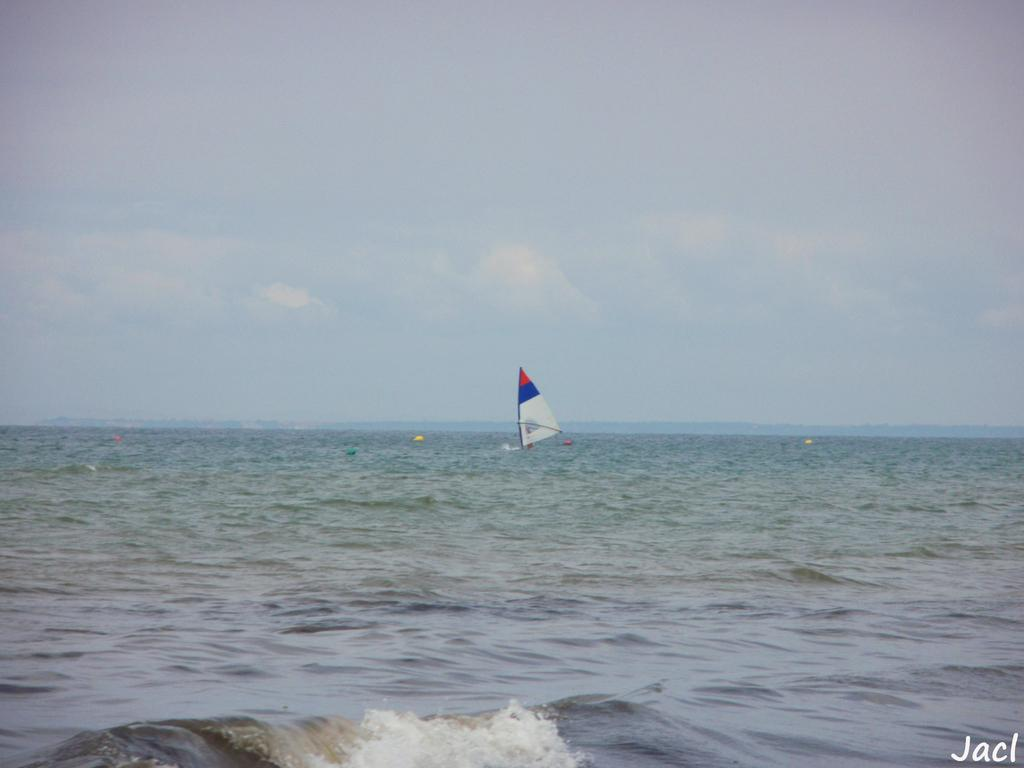What is the primary element in the image? There is water in the image. What can be seen floating in the water? There are yellow objects in the water. What type of vehicle is present in the water? There is a sailing boat in the water. What is visible in the background of the image? There are clouds and the sky in the background of the image, as well as the water. What type of pies are being served on the branch in the image? There is no branch or pies present in the image. What scientific theory is being discussed by the clouds in the image? The clouds in the image are not discussing any scientific theory; they are simply part of the background. 